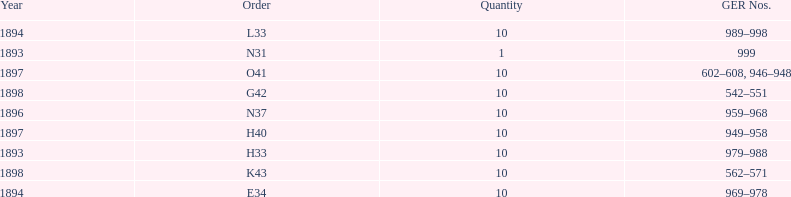Which order was the next order after l33? E34. 